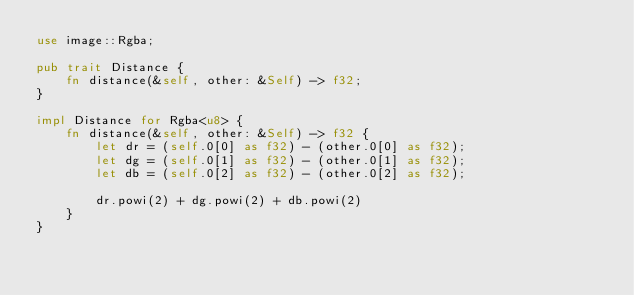<code> <loc_0><loc_0><loc_500><loc_500><_Rust_>use image::Rgba;

pub trait Distance {
    fn distance(&self, other: &Self) -> f32;
}

impl Distance for Rgba<u8> {
    fn distance(&self, other: &Self) -> f32 {
        let dr = (self.0[0] as f32) - (other.0[0] as f32);
        let dg = (self.0[1] as f32) - (other.0[1] as f32);
        let db = (self.0[2] as f32) - (other.0[2] as f32);

        dr.powi(2) + dg.powi(2) + db.powi(2)
    }
}
</code> 